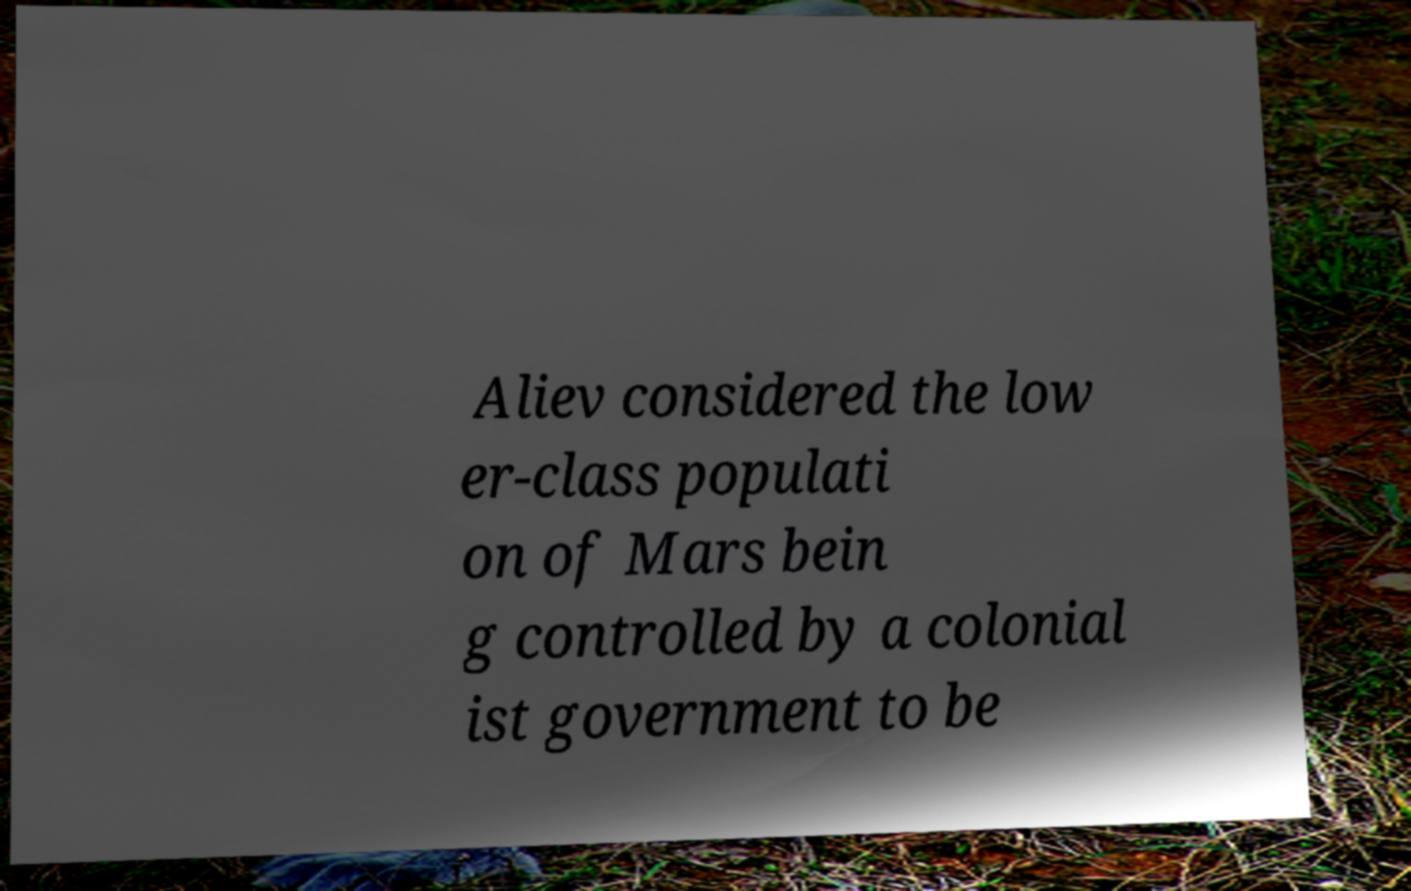What messages or text are displayed in this image? I need them in a readable, typed format. Aliev considered the low er-class populati on of Mars bein g controlled by a colonial ist government to be 